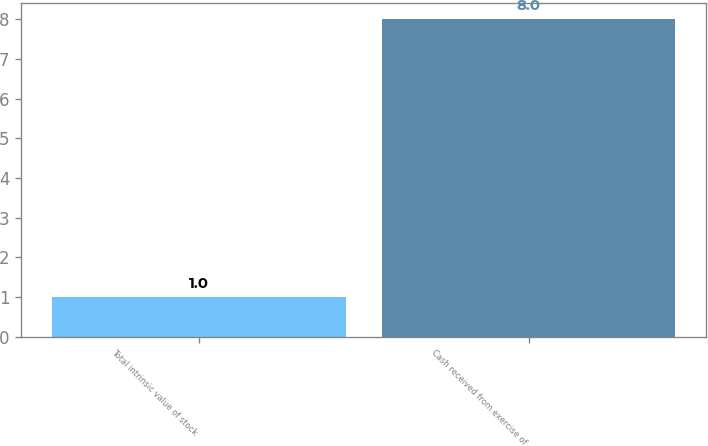Convert chart. <chart><loc_0><loc_0><loc_500><loc_500><bar_chart><fcel>Total intrinsic value of stock<fcel>Cash received from exercise of<nl><fcel>1<fcel>8<nl></chart> 